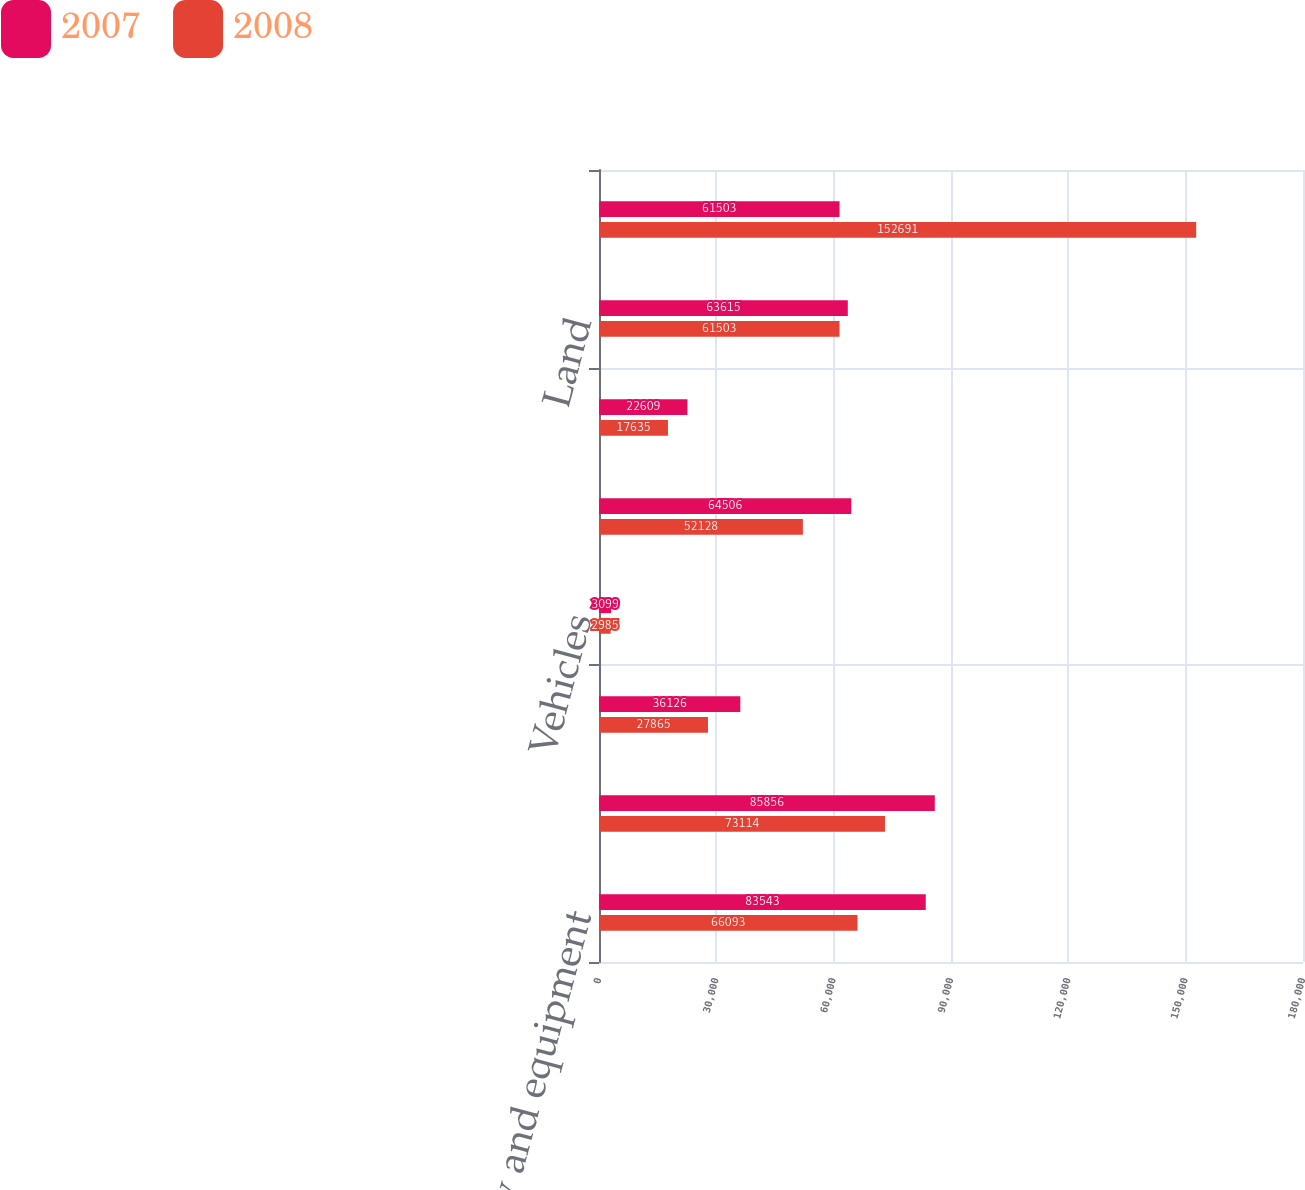Convert chart. <chart><loc_0><loc_0><loc_500><loc_500><stacked_bar_chart><ecel><fcel>Machinery and equipment<fcel>Computer equipment<fcel>Furniture and fixtures<fcel>Vehicles<fcel>Clinical demonstration and<fcel>Leasehold improvements<fcel>Land<fcel>Buildings<nl><fcel>2007<fcel>83543<fcel>85856<fcel>36126<fcel>3099<fcel>64506<fcel>22609<fcel>63615<fcel>61503<nl><fcel>2008<fcel>66093<fcel>73114<fcel>27865<fcel>2985<fcel>52128<fcel>17635<fcel>61503<fcel>152691<nl></chart> 